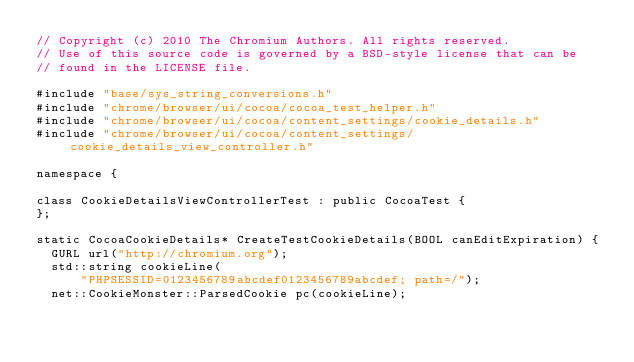Convert code to text. <code><loc_0><loc_0><loc_500><loc_500><_ObjectiveC_>// Copyright (c) 2010 The Chromium Authors. All rights reserved.
// Use of this source code is governed by a BSD-style license that can be
// found in the LICENSE file.

#include "base/sys_string_conversions.h"
#include "chrome/browser/ui/cocoa/cocoa_test_helper.h"
#include "chrome/browser/ui/cocoa/content_settings/cookie_details.h"
#include "chrome/browser/ui/cocoa/content_settings/cookie_details_view_controller.h"

namespace {

class CookieDetailsViewControllerTest : public CocoaTest {
};

static CocoaCookieDetails* CreateTestCookieDetails(BOOL canEditExpiration) {
  GURL url("http://chromium.org");
  std::string cookieLine(
      "PHPSESSID=0123456789abcdef0123456789abcdef; path=/");
  net::CookieMonster::ParsedCookie pc(cookieLine);</code> 